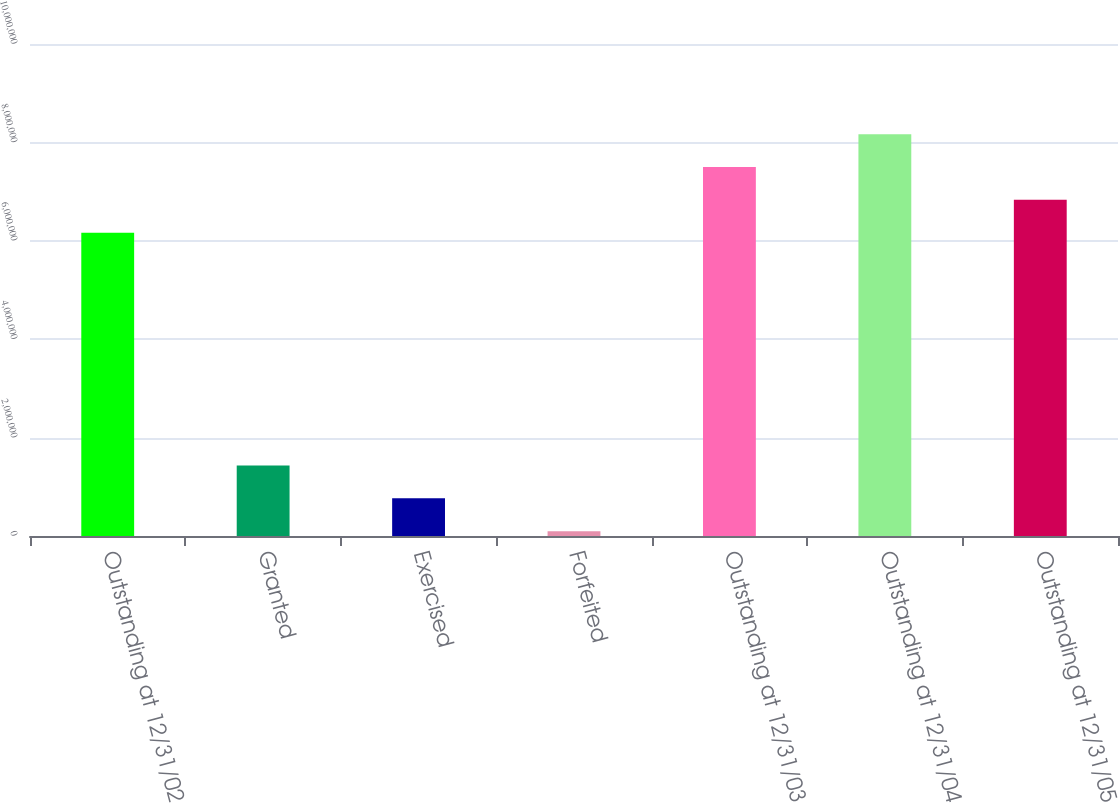Convert chart to OTSL. <chart><loc_0><loc_0><loc_500><loc_500><bar_chart><fcel>Outstanding at 12/31/02<fcel>Granted<fcel>Exercised<fcel>Forfeited<fcel>Outstanding at 12/31/03<fcel>Outstanding at 12/31/04<fcel>Outstanding at 12/31/05<nl><fcel>6.16615e+06<fcel>1.43105e+06<fcel>765025<fcel>99000<fcel>7.4982e+06<fcel>8.16423e+06<fcel>6.83218e+06<nl></chart> 